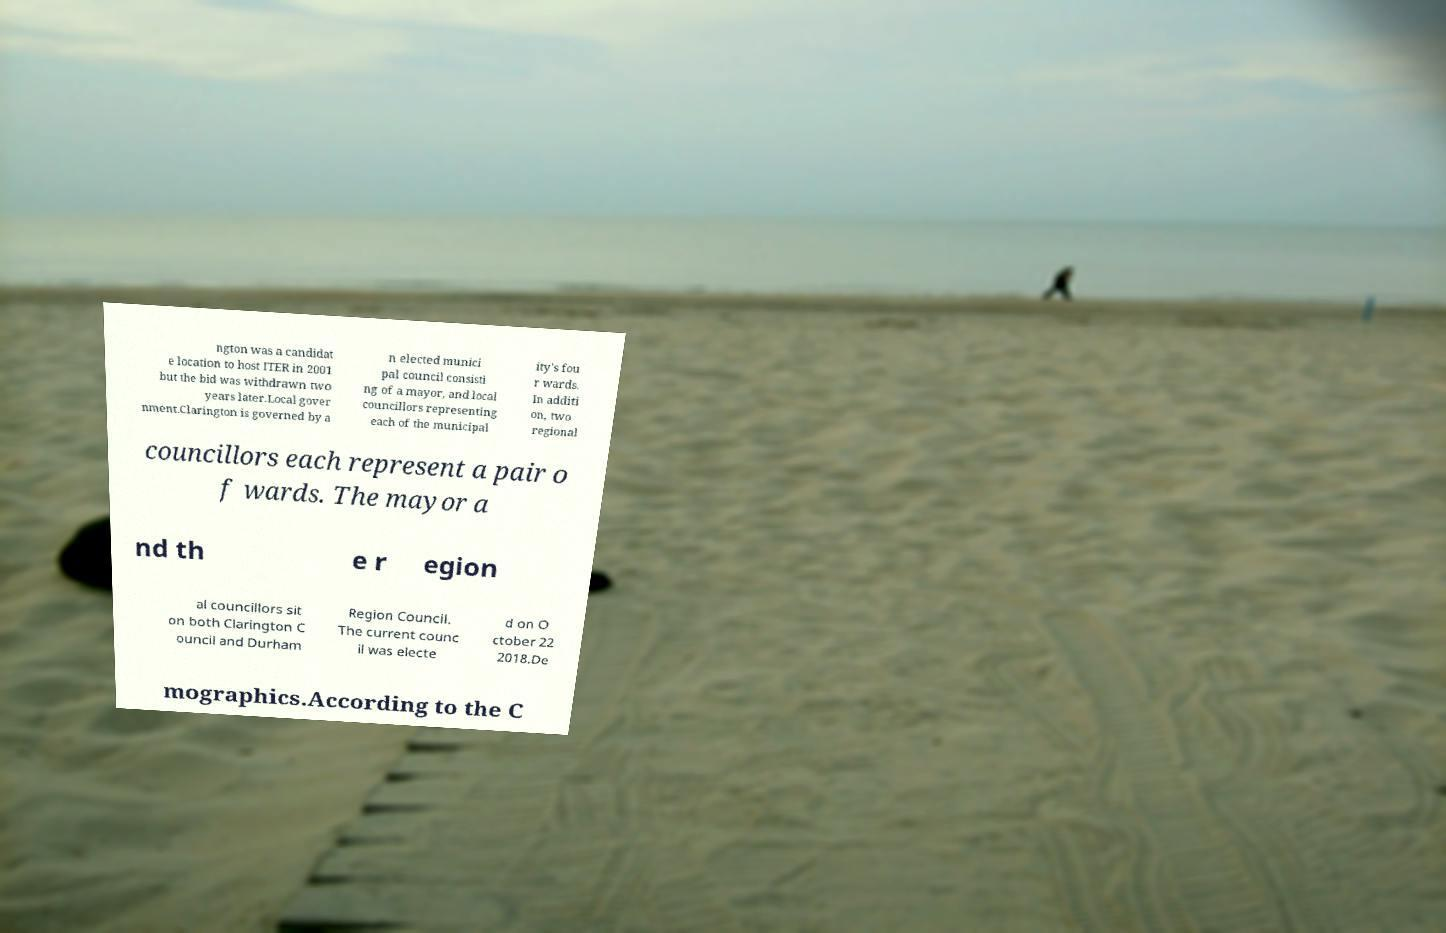Please identify and transcribe the text found in this image. ngton was a candidat e location to host ITER in 2001 but the bid was withdrawn two years later.Local gover nment.Clarington is governed by a n elected munici pal council consisti ng of a mayor, and local councillors representing each of the municipal ity's fou r wards. In additi on, two regional councillors each represent a pair o f wards. The mayor a nd th e r egion al councillors sit on both Clarington C ouncil and Durham Region Council. The current counc il was electe d on O ctober 22 2018.De mographics.According to the C 